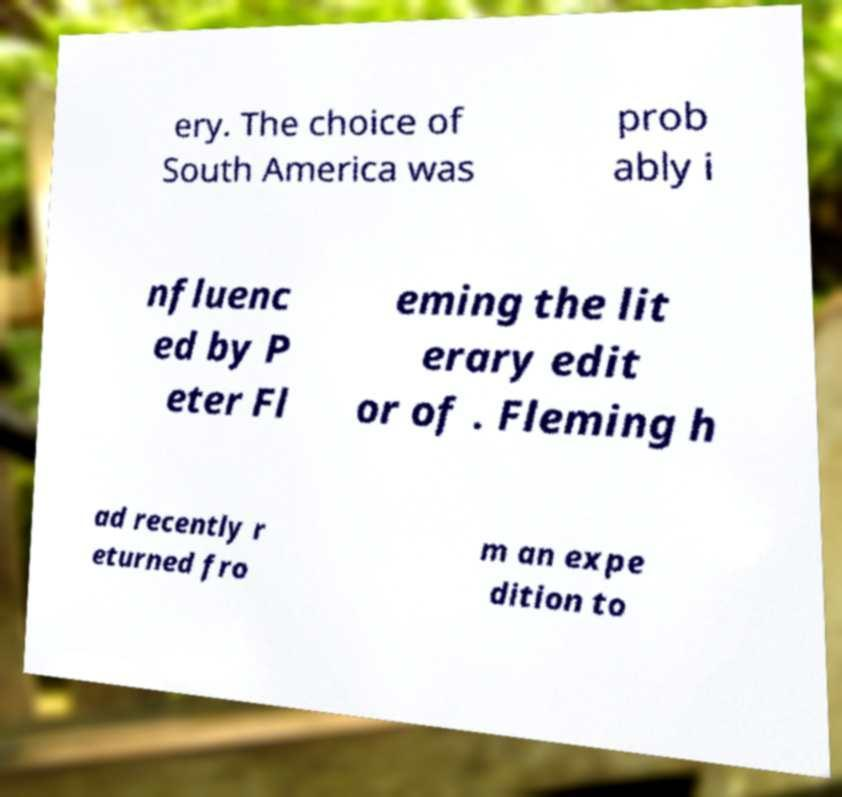For documentation purposes, I need the text within this image transcribed. Could you provide that? ery. The choice of South America was prob ably i nfluenc ed by P eter Fl eming the lit erary edit or of . Fleming h ad recently r eturned fro m an expe dition to 